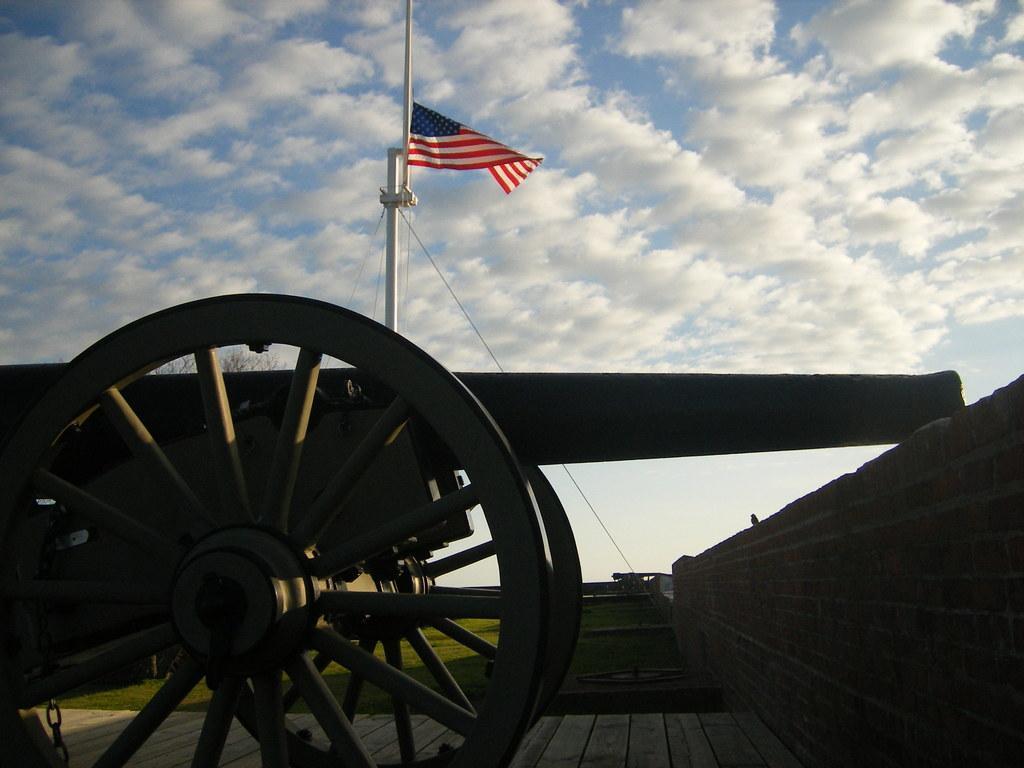Can you describe this image briefly? In the foreground of this image, there is a cannon,. On the right, there is a wall. In the background, there is a flag, grassland and the sky. 